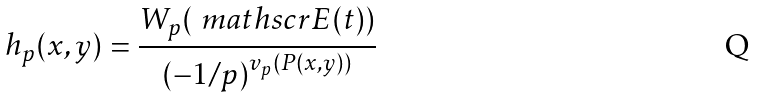<formula> <loc_0><loc_0><loc_500><loc_500>h _ { p } ( x , y ) = \frac { W _ { p } ( \ m a t h s c r { E } ( t ) ) } { ( - 1 / p ) ^ { v _ { p } ( P ( x , y ) ) } }</formula> 